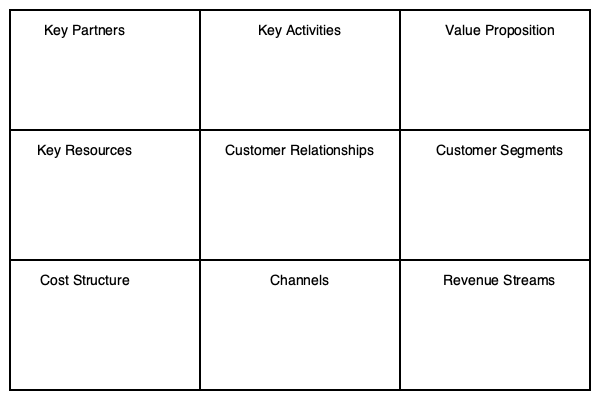As an engineering student with a unique invention, which component of the Business Model Canvas should you focus on first to clearly articulate the benefits of your innovation to potential business partners? To answer this question, let's consider the components of the Business Model Canvas and their relevance to your situation as an engineering student with a unique invention:

1. Value Proposition: This component describes the product or service that creates value for a specific customer segment. For a unique invention, this is crucial as it defines what problem your invention solves or what need it fulfills.

2. Customer Segments: While important, this comes after clearly defining your value proposition.

3. Key Activities: These are the most important activities your business needs to perform to be successful. For an invention, this might include R&D or manufacturing, but it's not the first focus when seeking a business partner.

4. Key Resources: These are the assets required to deliver your value proposition. For an invention, this might include patents or specialized equipment, but again, it's not the primary focus when pitching to a potential partner.

5. Key Partners: This is what you're looking for, but you need to articulate your value proposition first to attract these partners.

6. Customer Relationships, Channels, Cost Structure, and Revenue Streams: These are important components but are typically developed after the value proposition is clearly defined.

Given that you're looking for a business partner to bring your invention to market, the most critical first step is to clearly articulate the benefits and unique aspects of your invention. This falls squarely within the Value Proposition component of the Business Model Canvas.

By focusing on the Value Proposition first, you can clearly communicate what your invention does, why it's unique, and how it solves a problem or fulfills a need in the market. This information is crucial for attracting potential business partners who can help bring your invention to market.
Answer: Value Proposition 